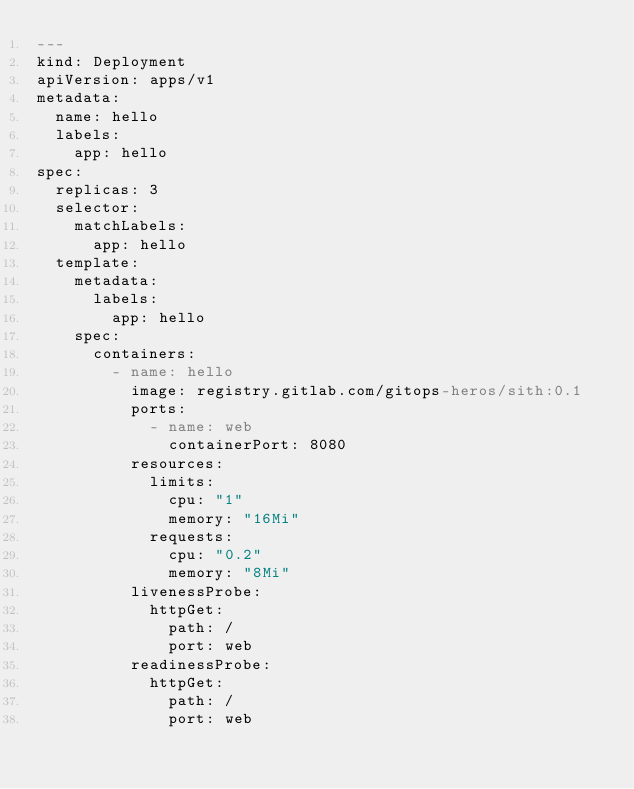Convert code to text. <code><loc_0><loc_0><loc_500><loc_500><_YAML_>---
kind: Deployment
apiVersion: apps/v1
metadata:
  name: hello
  labels:
    app: hello
spec:
  replicas: 3
  selector:
    matchLabels:
      app: hello
  template:
    metadata:
      labels:
        app: hello
    spec:
      containers:
        - name: hello
          image: registry.gitlab.com/gitops-heros/sith:0.1
          ports:
            - name: web
              containerPort: 8080
          resources:
            limits:
              cpu: "1"
              memory: "16Mi"
            requests:
              cpu: "0.2"
              memory: "8Mi"
          livenessProbe:
            httpGet:
              path: /
              port: web
          readinessProbe:
            httpGet:
              path: /
              port: web
</code> 